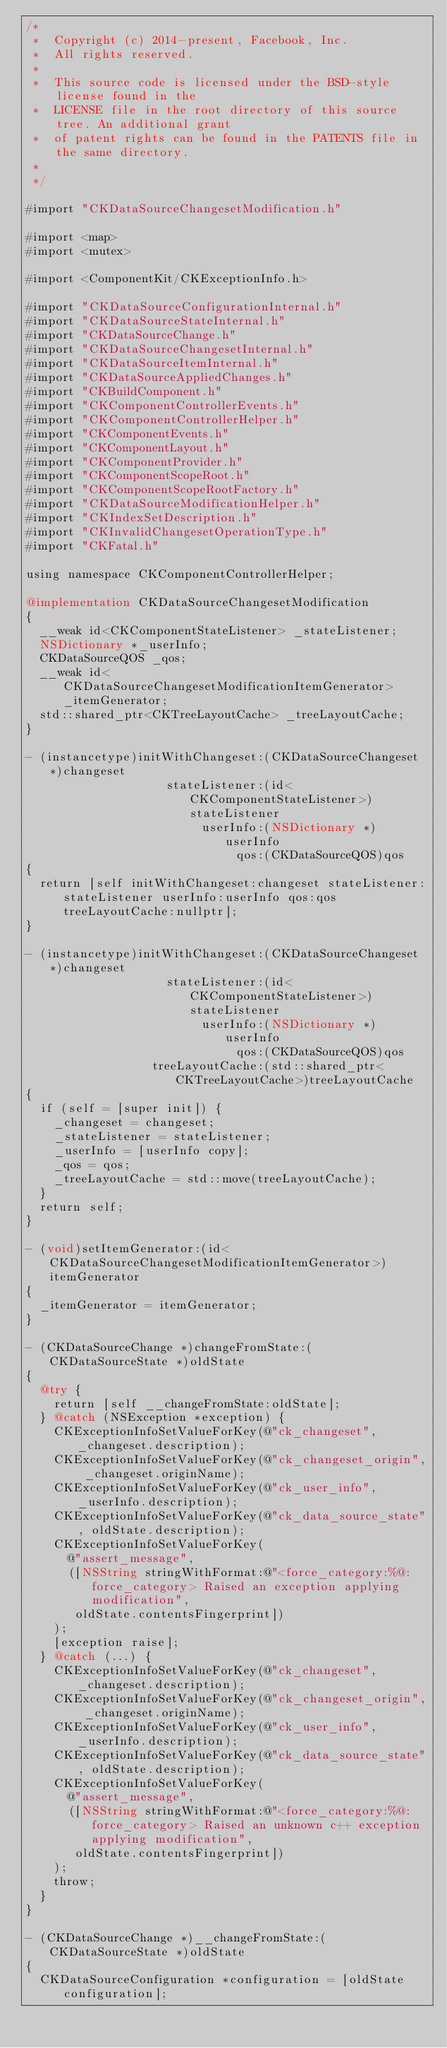Convert code to text. <code><loc_0><loc_0><loc_500><loc_500><_ObjectiveC_>/*
 *  Copyright (c) 2014-present, Facebook, Inc.
 *  All rights reserved.
 *
 *  This source code is licensed under the BSD-style license found in the
 *  LICENSE file in the root directory of this source tree. An additional grant
 *  of patent rights can be found in the PATENTS file in the same directory.
 *
 */

#import "CKDataSourceChangesetModification.h"

#import <map>
#import <mutex>

#import <ComponentKit/CKExceptionInfo.h>

#import "CKDataSourceConfigurationInternal.h"
#import "CKDataSourceStateInternal.h"
#import "CKDataSourceChange.h"
#import "CKDataSourceChangesetInternal.h"
#import "CKDataSourceItemInternal.h"
#import "CKDataSourceAppliedChanges.h"
#import "CKBuildComponent.h"
#import "CKComponentControllerEvents.h"
#import "CKComponentControllerHelper.h"
#import "CKComponentEvents.h"
#import "CKComponentLayout.h"
#import "CKComponentProvider.h"
#import "CKComponentScopeRoot.h"
#import "CKComponentScopeRootFactory.h"
#import "CKDataSourceModificationHelper.h"
#import "CKIndexSetDescription.h"
#import "CKInvalidChangesetOperationType.h"
#import "CKFatal.h"

using namespace CKComponentControllerHelper;

@implementation CKDataSourceChangesetModification
{
  __weak id<CKComponentStateListener> _stateListener;
  NSDictionary *_userInfo;
  CKDataSourceQOS _qos;
  __weak id<CKDataSourceChangesetModificationItemGenerator> _itemGenerator;
  std::shared_ptr<CKTreeLayoutCache> _treeLayoutCache;
}

- (instancetype)initWithChangeset:(CKDataSourceChangeset *)changeset
                    stateListener:(id<CKComponentStateListener>)stateListener
                         userInfo:(NSDictionary *)userInfo
                              qos:(CKDataSourceQOS)qos
{
  return [self initWithChangeset:changeset stateListener:stateListener userInfo:userInfo qos:qos treeLayoutCache:nullptr];
}

- (instancetype)initWithChangeset:(CKDataSourceChangeset *)changeset
                    stateListener:(id<CKComponentStateListener>)stateListener
                         userInfo:(NSDictionary *)userInfo
                              qos:(CKDataSourceQOS)qos
                  treeLayoutCache:(std::shared_ptr<CKTreeLayoutCache>)treeLayoutCache
{
  if (self = [super init]) {
    _changeset = changeset;
    _stateListener = stateListener;
    _userInfo = [userInfo copy];
    _qos = qos;
    _treeLayoutCache = std::move(treeLayoutCache);
  }
  return self;
}

- (void)setItemGenerator:(id<CKDataSourceChangesetModificationItemGenerator>)itemGenerator
{
  _itemGenerator = itemGenerator;
}

- (CKDataSourceChange *)changeFromState:(CKDataSourceState *)oldState
{
  @try {
    return [self __changeFromState:oldState];
  } @catch (NSException *exception) {
    CKExceptionInfoSetValueForKey(@"ck_changeset", _changeset.description);
    CKExceptionInfoSetValueForKey(@"ck_changeset_origin", _changeset.originName);
    CKExceptionInfoSetValueForKey(@"ck_user_info", _userInfo.description);
    CKExceptionInfoSetValueForKey(@"ck_data_source_state", oldState.description);
    CKExceptionInfoSetValueForKey(
      @"assert_message",
      ([NSString stringWithFormat:@"<force_category:%@:force_category> Raised an exception applying modification",
       oldState.contentsFingerprint])
    );
    [exception raise];
  } @catch (...) {
    CKExceptionInfoSetValueForKey(@"ck_changeset", _changeset.description);
    CKExceptionInfoSetValueForKey(@"ck_changeset_origin", _changeset.originName);
    CKExceptionInfoSetValueForKey(@"ck_user_info", _userInfo.description);
    CKExceptionInfoSetValueForKey(@"ck_data_source_state", oldState.description);
    CKExceptionInfoSetValueForKey(
      @"assert_message",
      ([NSString stringWithFormat:@"<force_category:%@:force_category> Raised an unknown c++ exception applying modification",
       oldState.contentsFingerprint])
    );
    throw;
  }
}

- (CKDataSourceChange *)__changeFromState:(CKDataSourceState *)oldState
{
  CKDataSourceConfiguration *configuration = [oldState configuration];</code> 